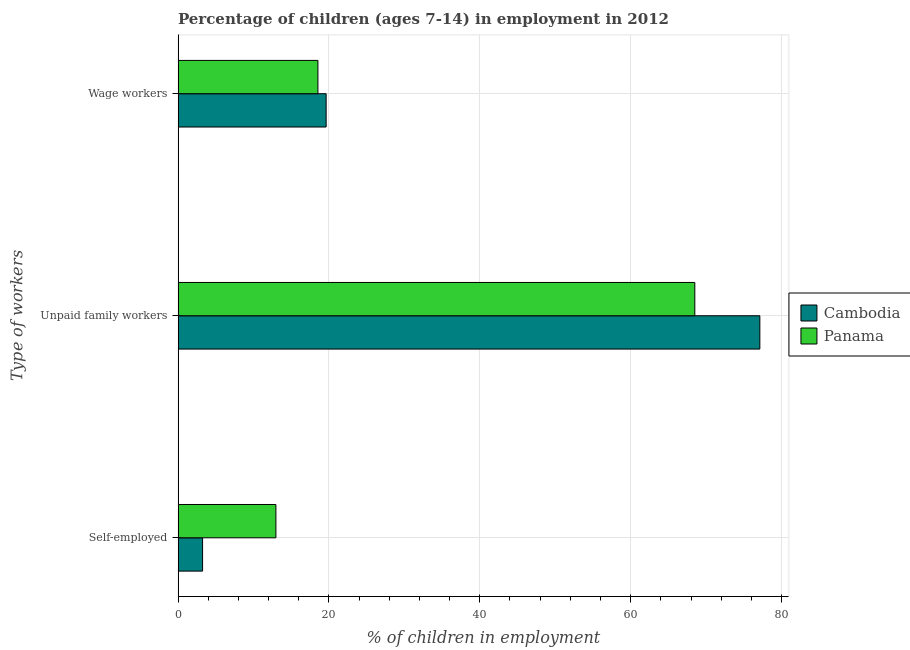How many bars are there on the 1st tick from the top?
Your answer should be very brief. 2. How many bars are there on the 2nd tick from the bottom?
Give a very brief answer. 2. What is the label of the 2nd group of bars from the top?
Offer a terse response. Unpaid family workers. What is the percentage of children employed as unpaid family workers in Cambodia?
Your answer should be compact. 77.12. Across all countries, what is the maximum percentage of self employed children?
Make the answer very short. 12.97. Across all countries, what is the minimum percentage of children employed as wage workers?
Your response must be concise. 18.54. In which country was the percentage of children employed as unpaid family workers maximum?
Make the answer very short. Cambodia. In which country was the percentage of self employed children minimum?
Offer a terse response. Cambodia. What is the total percentage of children employed as unpaid family workers in the graph?
Keep it short and to the point. 145.62. What is the difference between the percentage of self employed children in Panama and that in Cambodia?
Offer a very short reply. 9.72. What is the difference between the percentage of children employed as unpaid family workers in Panama and the percentage of children employed as wage workers in Cambodia?
Provide a succinct answer. 48.87. What is the average percentage of children employed as wage workers per country?
Make the answer very short. 19.09. What is the difference between the percentage of self employed children and percentage of children employed as wage workers in Panama?
Keep it short and to the point. -5.57. In how many countries, is the percentage of self employed children greater than 52 %?
Offer a terse response. 0. What is the ratio of the percentage of children employed as unpaid family workers in Cambodia to that in Panama?
Offer a terse response. 1.13. Is the percentage of children employed as wage workers in Cambodia less than that in Panama?
Your response must be concise. No. Is the difference between the percentage of children employed as unpaid family workers in Panama and Cambodia greater than the difference between the percentage of children employed as wage workers in Panama and Cambodia?
Your answer should be compact. No. What is the difference between the highest and the second highest percentage of children employed as wage workers?
Ensure brevity in your answer.  1.09. What is the difference between the highest and the lowest percentage of children employed as unpaid family workers?
Make the answer very short. 8.62. What does the 2nd bar from the top in Unpaid family workers represents?
Provide a succinct answer. Cambodia. What does the 2nd bar from the bottom in Wage workers represents?
Ensure brevity in your answer.  Panama. Is it the case that in every country, the sum of the percentage of self employed children and percentage of children employed as unpaid family workers is greater than the percentage of children employed as wage workers?
Give a very brief answer. Yes. How many bars are there?
Your response must be concise. 6. Are all the bars in the graph horizontal?
Make the answer very short. Yes. How many countries are there in the graph?
Offer a terse response. 2. What is the difference between two consecutive major ticks on the X-axis?
Offer a very short reply. 20. Are the values on the major ticks of X-axis written in scientific E-notation?
Give a very brief answer. No. Where does the legend appear in the graph?
Ensure brevity in your answer.  Center right. How are the legend labels stacked?
Ensure brevity in your answer.  Vertical. What is the title of the graph?
Ensure brevity in your answer.  Percentage of children (ages 7-14) in employment in 2012. Does "Antigua and Barbuda" appear as one of the legend labels in the graph?
Keep it short and to the point. No. What is the label or title of the X-axis?
Ensure brevity in your answer.  % of children in employment. What is the label or title of the Y-axis?
Ensure brevity in your answer.  Type of workers. What is the % of children in employment of Panama in Self-employed?
Your response must be concise. 12.97. What is the % of children in employment in Cambodia in Unpaid family workers?
Provide a succinct answer. 77.12. What is the % of children in employment in Panama in Unpaid family workers?
Your answer should be very brief. 68.5. What is the % of children in employment in Cambodia in Wage workers?
Give a very brief answer. 19.63. What is the % of children in employment of Panama in Wage workers?
Provide a succinct answer. 18.54. Across all Type of workers, what is the maximum % of children in employment of Cambodia?
Make the answer very short. 77.12. Across all Type of workers, what is the maximum % of children in employment in Panama?
Give a very brief answer. 68.5. Across all Type of workers, what is the minimum % of children in employment in Cambodia?
Ensure brevity in your answer.  3.25. Across all Type of workers, what is the minimum % of children in employment of Panama?
Give a very brief answer. 12.97. What is the total % of children in employment of Cambodia in the graph?
Provide a short and direct response. 100. What is the total % of children in employment of Panama in the graph?
Offer a very short reply. 100.01. What is the difference between the % of children in employment of Cambodia in Self-employed and that in Unpaid family workers?
Your response must be concise. -73.87. What is the difference between the % of children in employment in Panama in Self-employed and that in Unpaid family workers?
Give a very brief answer. -55.53. What is the difference between the % of children in employment of Cambodia in Self-employed and that in Wage workers?
Your response must be concise. -16.38. What is the difference between the % of children in employment in Panama in Self-employed and that in Wage workers?
Your answer should be compact. -5.57. What is the difference between the % of children in employment in Cambodia in Unpaid family workers and that in Wage workers?
Provide a succinct answer. 57.49. What is the difference between the % of children in employment in Panama in Unpaid family workers and that in Wage workers?
Offer a very short reply. 49.96. What is the difference between the % of children in employment of Cambodia in Self-employed and the % of children in employment of Panama in Unpaid family workers?
Keep it short and to the point. -65.25. What is the difference between the % of children in employment of Cambodia in Self-employed and the % of children in employment of Panama in Wage workers?
Provide a succinct answer. -15.29. What is the difference between the % of children in employment of Cambodia in Unpaid family workers and the % of children in employment of Panama in Wage workers?
Provide a short and direct response. 58.58. What is the average % of children in employment of Cambodia per Type of workers?
Your answer should be very brief. 33.33. What is the average % of children in employment of Panama per Type of workers?
Offer a terse response. 33.34. What is the difference between the % of children in employment in Cambodia and % of children in employment in Panama in Self-employed?
Provide a succinct answer. -9.72. What is the difference between the % of children in employment of Cambodia and % of children in employment of Panama in Unpaid family workers?
Offer a terse response. 8.62. What is the difference between the % of children in employment of Cambodia and % of children in employment of Panama in Wage workers?
Ensure brevity in your answer.  1.09. What is the ratio of the % of children in employment of Cambodia in Self-employed to that in Unpaid family workers?
Keep it short and to the point. 0.04. What is the ratio of the % of children in employment of Panama in Self-employed to that in Unpaid family workers?
Ensure brevity in your answer.  0.19. What is the ratio of the % of children in employment in Cambodia in Self-employed to that in Wage workers?
Your response must be concise. 0.17. What is the ratio of the % of children in employment of Panama in Self-employed to that in Wage workers?
Your answer should be compact. 0.7. What is the ratio of the % of children in employment in Cambodia in Unpaid family workers to that in Wage workers?
Your answer should be very brief. 3.93. What is the ratio of the % of children in employment in Panama in Unpaid family workers to that in Wage workers?
Provide a succinct answer. 3.69. What is the difference between the highest and the second highest % of children in employment of Cambodia?
Ensure brevity in your answer.  57.49. What is the difference between the highest and the second highest % of children in employment in Panama?
Offer a terse response. 49.96. What is the difference between the highest and the lowest % of children in employment in Cambodia?
Keep it short and to the point. 73.87. What is the difference between the highest and the lowest % of children in employment of Panama?
Your response must be concise. 55.53. 